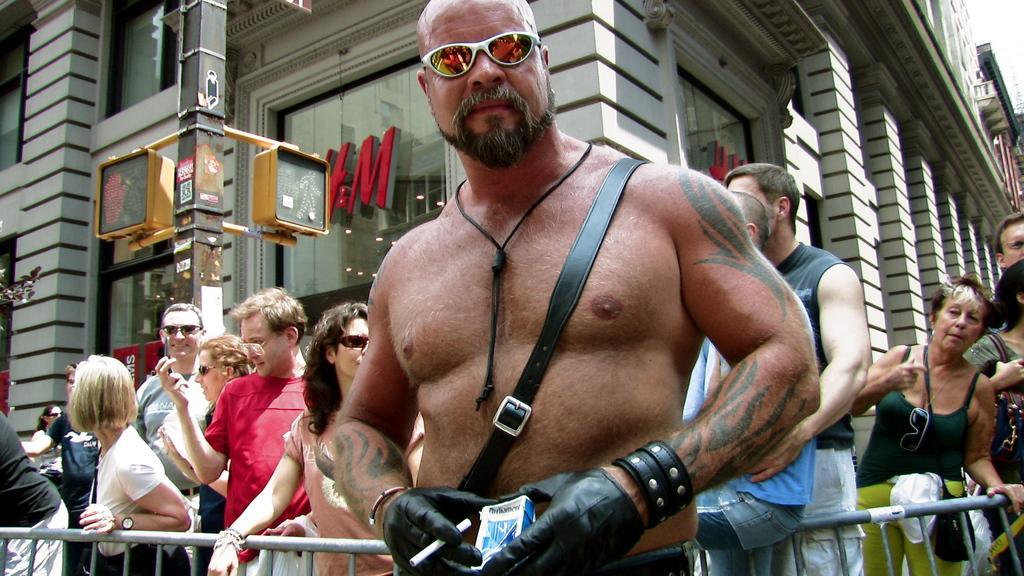In one or two sentences, can you explain what this image depicts? In this image I can see a person wearing black colored dress is standing and holding few objects in his hands. I can see the railing and few persons standing behind him. In the background I can see a building, a pole, few boards to the pole and the sky. 